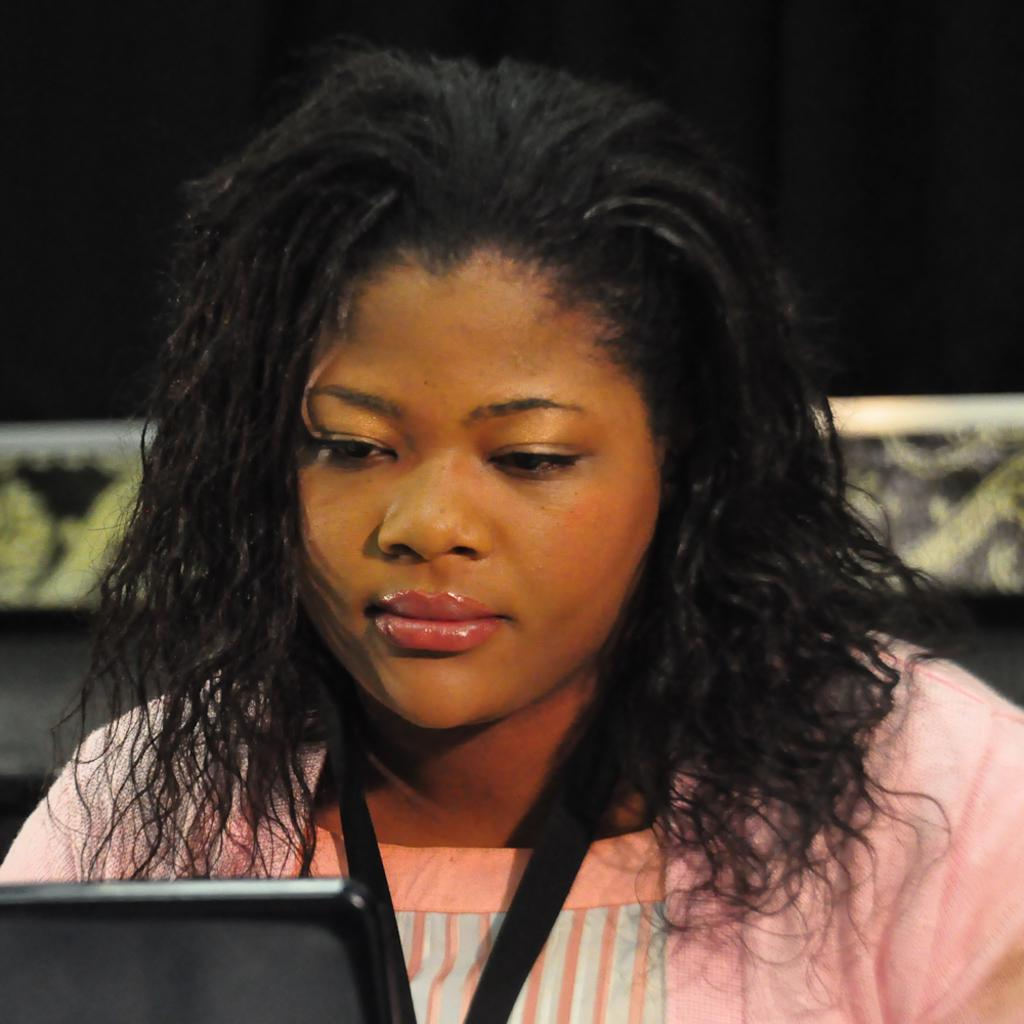Who is in the image? There is a woman in the image. What is the woman wearing that provides identification? The woman is wearing an ID card. What can be seen on the bottom left of the image? There is an object on the bottom left of the image. Can you describe the background of the image? The background of the image is not clear. How many icicles are hanging from the trees in the image? There are no trees or icicles present in the image. What type of insect can be seen crawling on the woman's ID card in the image? There are no insects visible on the woman's ID card or anywhere else in the image. 